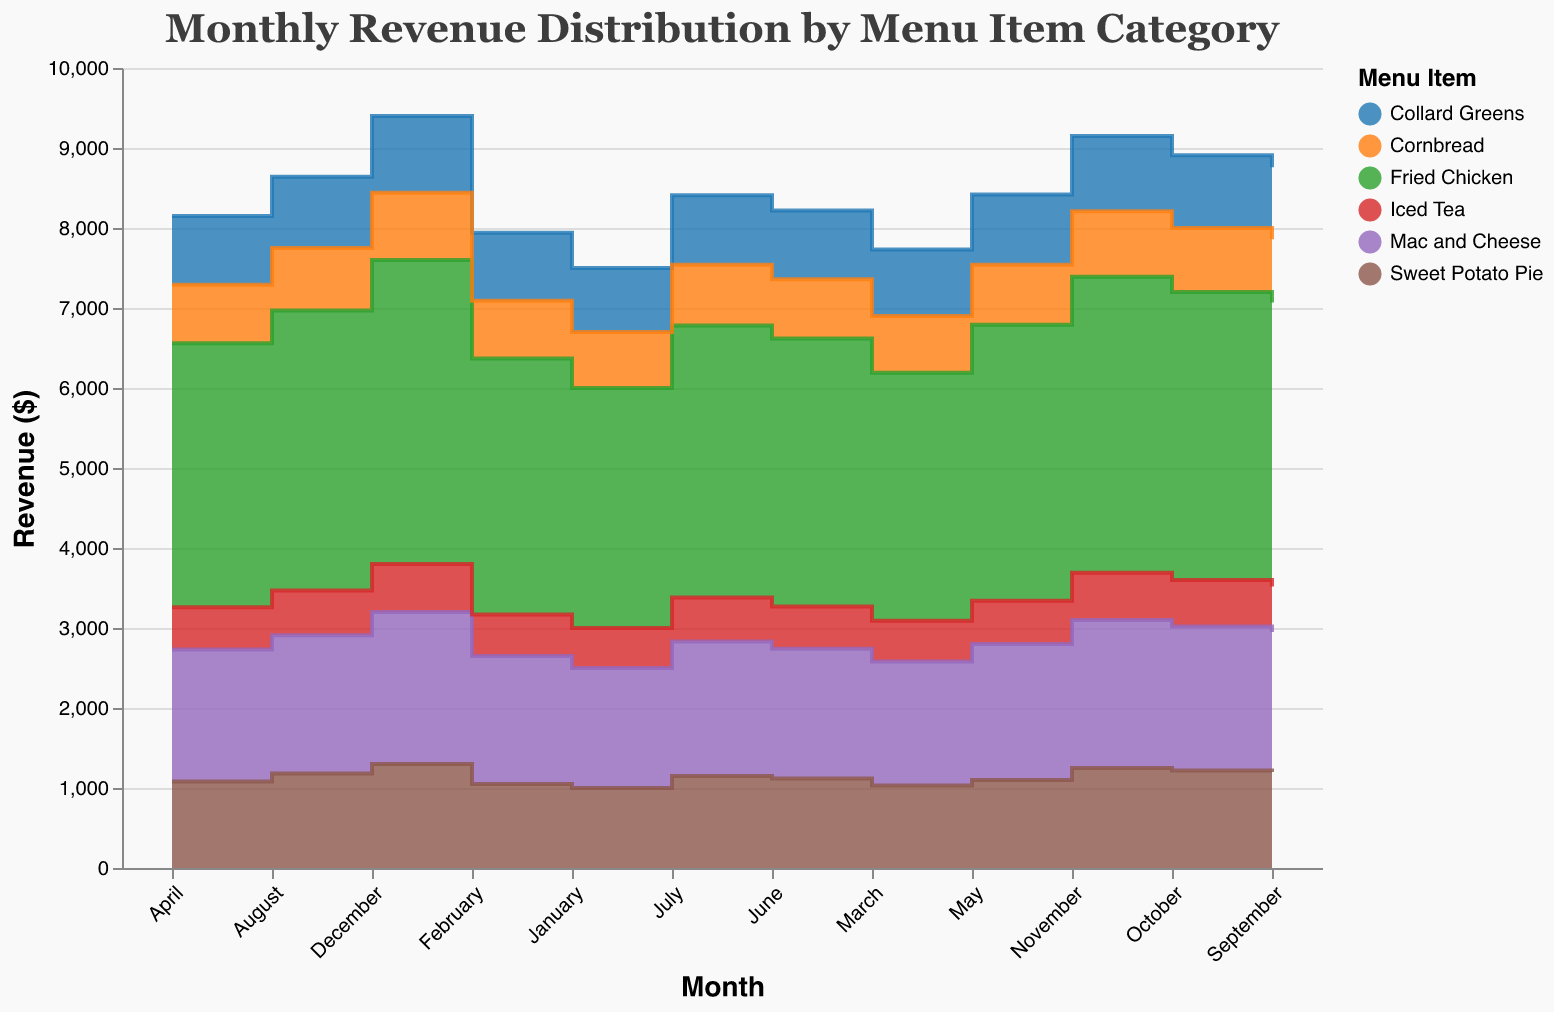What is the title of the chart? The title is located at the top of the chart and reads "Monthly Revenue Distribution by Menu Item Category".
Answer: Monthly Revenue Distribution by Menu Item Category What months are displayed on the x-axis? The months are displayed on the horizontal axis, with labels such as January, February, March, etc.
Answer: January, February, March, April, May, June, July, August, September, October, November, December Which menu item category has the highest revenue in December? By looking at the heights of the step areas in December, the "Fried Chicken" category reaches the highest point.
Answer: Fried Chicken How much revenue does Mac and Cheese generate in August? Locate the point on the step area for "Mac and Cheese" in August and note the value.
Answer: 1730 How does the revenue of Cornbread in June compare to that in July? The revenue for Cornbread in June is 740, and in July it is 760. So, the revenue increased by 20.
Answer: Increased by 20 Which month shows the highest total combined revenue for all categories? Add the revenue for each category per month, the month with the highest combined value is October.
Answer: October What is the average monthly revenue for Collard Greens over the year? Sum the monthly revenues of Collard Greens and divide by 12. The values are 800, 850, 830, 860, 880, 860, 870, 890, 900, 910, 940, 960. The total is 11350, and the average is 11350/12.
Answer: 946 Is there any menu item category that shows a revenue decline in any month? Scan through the step areas for any drops. "Collard Greens" shows a decline from May (880) to June (860).
Answer: Yes, Collard Greens What trend do you observe in the revenue of Sweet Potato Pie from January to December? The step area for "Sweet Potato Pie" shows a consistent upward trend from January (1000) to December (1300).
Answer: Consistent upward trend Which menu item categories generate more revenue than Iced Tea in July? Compare the revenue in July for Iced Tea (550) with other categories: Fried Chicken (3400), Mac and Cheese (1680), Collard Greens (870), Cornbread (760), Sweet Potato Pie (1150). All categories generate more except Iced Tea itself.
Answer: Fried Chicken, Mac and Cheese, Collard Greens, Cornbread, Sweet Potato Pie 